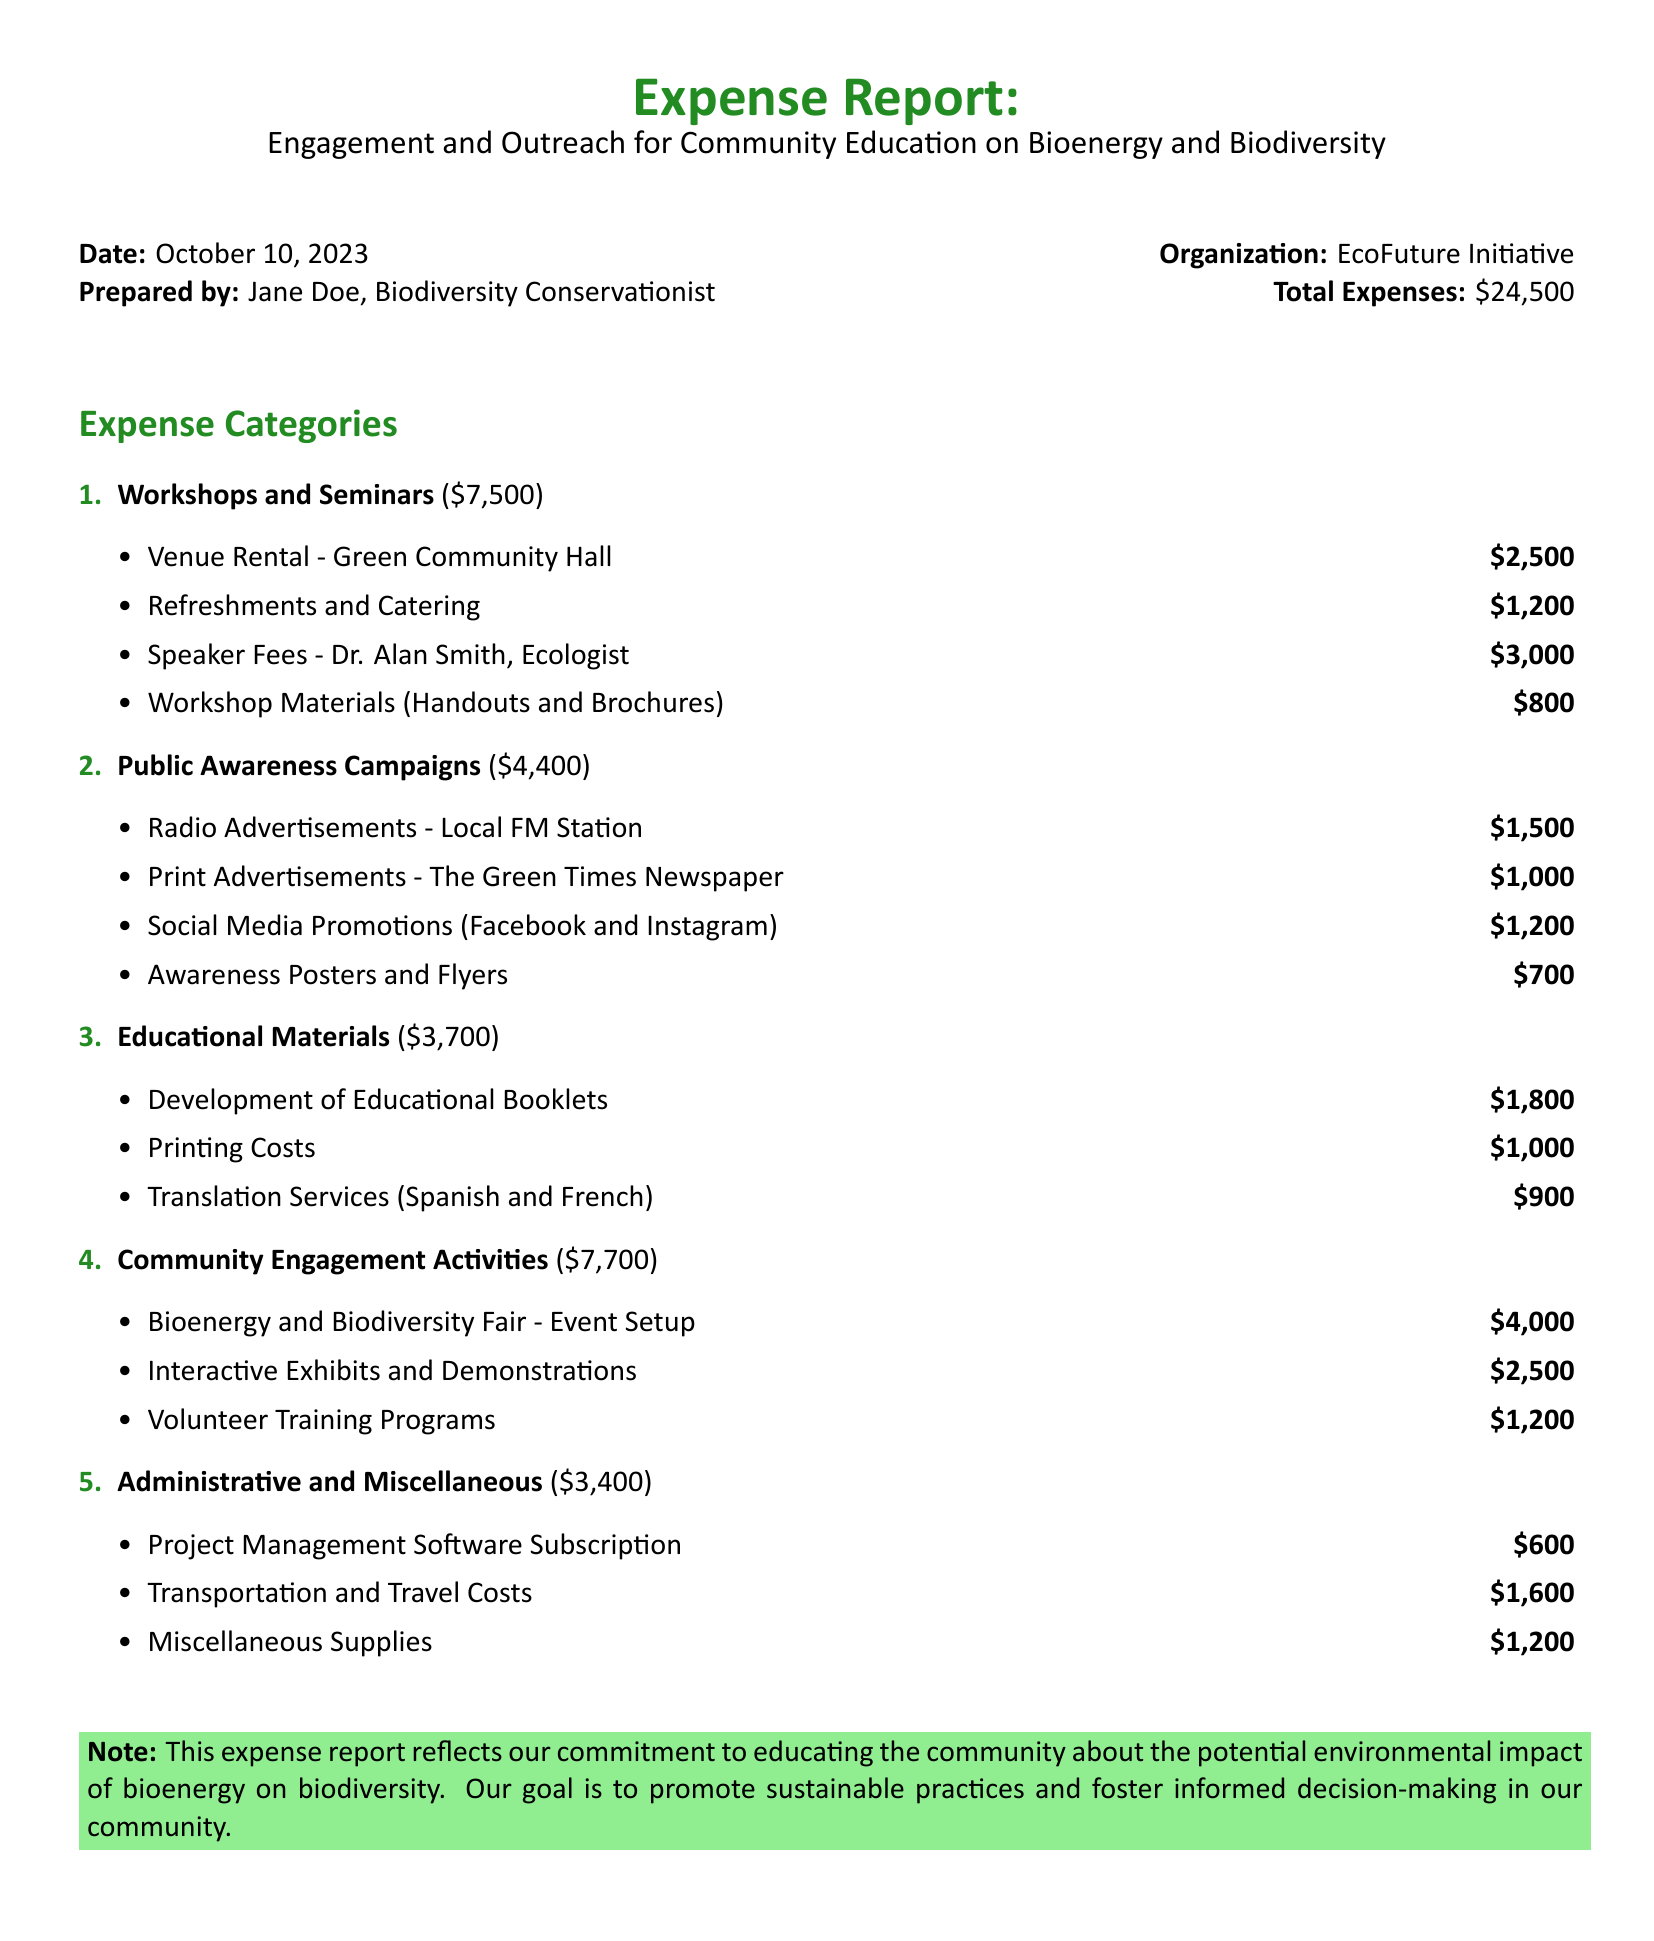What is the total expense amount? The total expense amount is stated clearly in the report, which sums all categories of expenses.
Answer: $24,500 Who prepared this report? The report indicates the individual who prepared it under the "Prepared by" section.
Answer: Jane Doe What is the date of the report? The date is specified at the beginning of the document, marking when the report was prepared.
Answer: October 10, 2023 How much was spent on community engagement activities? The report lists the total amount for community engagement activities as part of the expense categories.
Answer: $7,700 What was the cost for speaker fees? The expense report includes a specific item detailing the fees paid to the speaker.
Answer: $3,000 What is the budget allocation for workshops and seminars? The expense category clearly denotes the budget allocated for workshops and seminars.
Answer: $7,500 How much was allocated to educational materials? The amount allocated to educational materials is listed under its corresponding category in the expense report.
Answer: $3,700 Which venue was rented for events? The report mentions the name of the venue rented for the workshops and seminars.
Answer: Green Community Hall What was the cost of transportation and travel? The expense report includes a specific entry for transportation and travel costs.
Answer: $1,600 What was the purpose of this expense report? The note section of the report provides insight into the purpose of the expenses incurred.
Answer: Educating the community about the potential environmental impact of bioenergy on biodiversity 